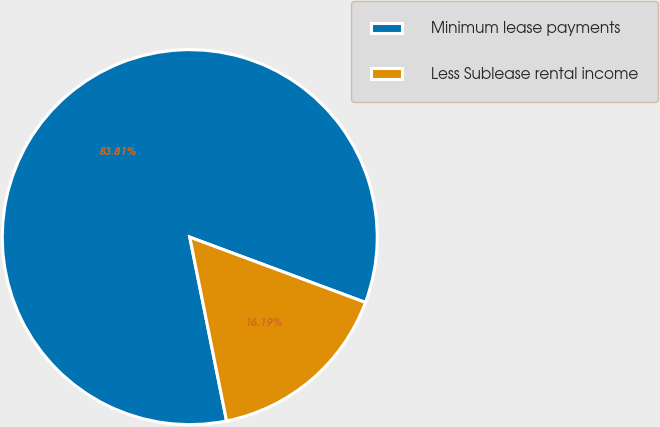Convert chart to OTSL. <chart><loc_0><loc_0><loc_500><loc_500><pie_chart><fcel>Minimum lease payments<fcel>Less Sublease rental income<nl><fcel>83.81%<fcel>16.19%<nl></chart> 